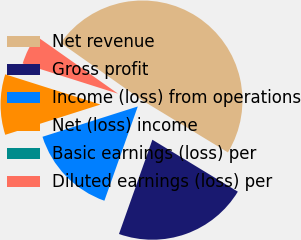Convert chart. <chart><loc_0><loc_0><loc_500><loc_500><pie_chart><fcel>Net revenue<fcel>Gross profit<fcel>Income (loss) from operations<fcel>Net (loss) income<fcel>Basic earnings (loss) per<fcel>Diluted earnings (loss) per<nl><fcel>48.92%<fcel>21.73%<fcel>14.68%<fcel>9.78%<fcel>0.0%<fcel>4.89%<nl></chart> 